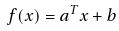Convert formula to latex. <formula><loc_0><loc_0><loc_500><loc_500>f ( x ) = a ^ { T } x + b</formula> 